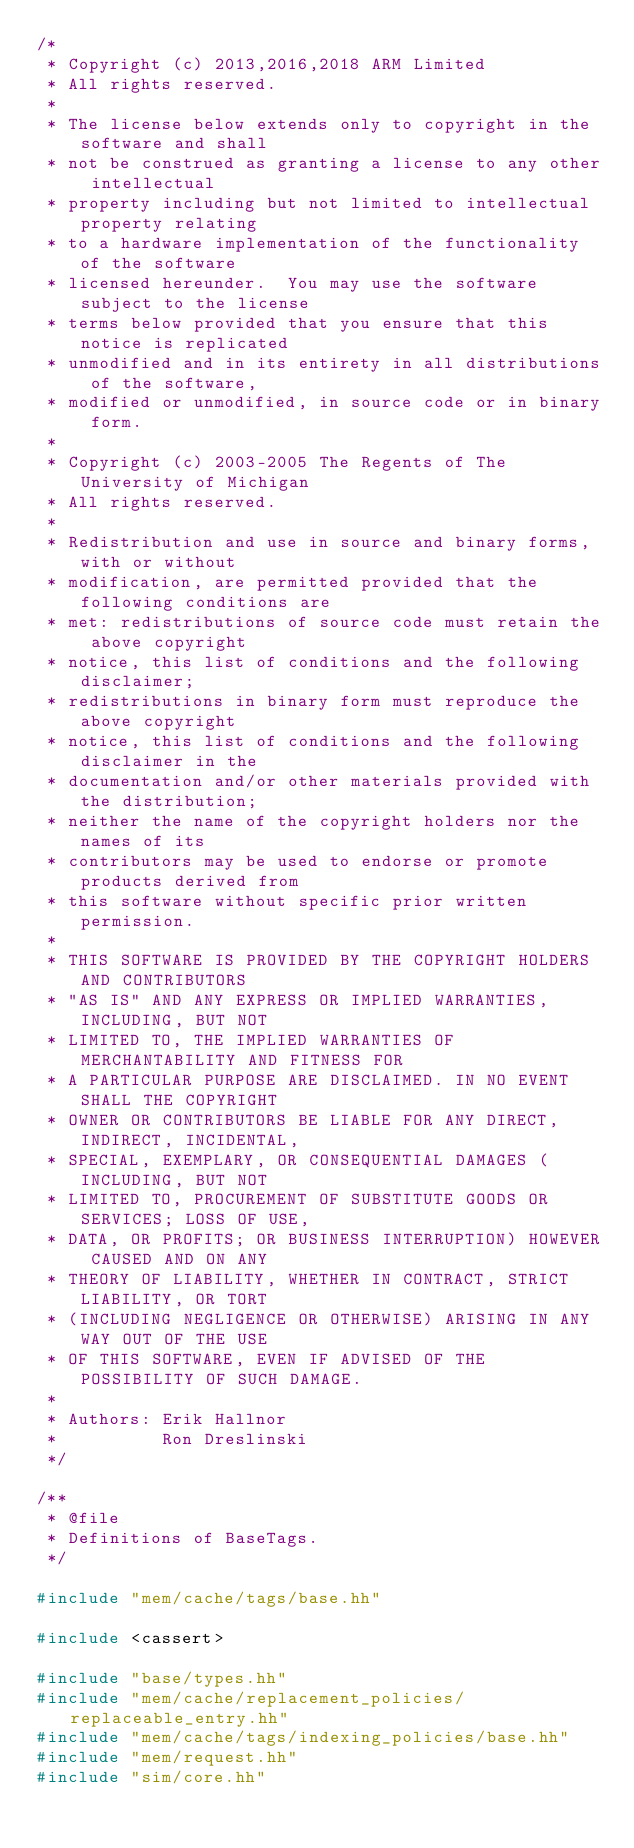Convert code to text. <code><loc_0><loc_0><loc_500><loc_500><_C++_>/*
 * Copyright (c) 2013,2016,2018 ARM Limited
 * All rights reserved.
 *
 * The license below extends only to copyright in the software and shall
 * not be construed as granting a license to any other intellectual
 * property including but not limited to intellectual property relating
 * to a hardware implementation of the functionality of the software
 * licensed hereunder.  You may use the software subject to the license
 * terms below provided that you ensure that this notice is replicated
 * unmodified and in its entirety in all distributions of the software,
 * modified or unmodified, in source code or in binary form.
 *
 * Copyright (c) 2003-2005 The Regents of The University of Michigan
 * All rights reserved.
 *
 * Redistribution and use in source and binary forms, with or without
 * modification, are permitted provided that the following conditions are
 * met: redistributions of source code must retain the above copyright
 * notice, this list of conditions and the following disclaimer;
 * redistributions in binary form must reproduce the above copyright
 * notice, this list of conditions and the following disclaimer in the
 * documentation and/or other materials provided with the distribution;
 * neither the name of the copyright holders nor the names of its
 * contributors may be used to endorse or promote products derived from
 * this software without specific prior written permission.
 *
 * THIS SOFTWARE IS PROVIDED BY THE COPYRIGHT HOLDERS AND CONTRIBUTORS
 * "AS IS" AND ANY EXPRESS OR IMPLIED WARRANTIES, INCLUDING, BUT NOT
 * LIMITED TO, THE IMPLIED WARRANTIES OF MERCHANTABILITY AND FITNESS FOR
 * A PARTICULAR PURPOSE ARE DISCLAIMED. IN NO EVENT SHALL THE COPYRIGHT
 * OWNER OR CONTRIBUTORS BE LIABLE FOR ANY DIRECT, INDIRECT, INCIDENTAL,
 * SPECIAL, EXEMPLARY, OR CONSEQUENTIAL DAMAGES (INCLUDING, BUT NOT
 * LIMITED TO, PROCUREMENT OF SUBSTITUTE GOODS OR SERVICES; LOSS OF USE,
 * DATA, OR PROFITS; OR BUSINESS INTERRUPTION) HOWEVER CAUSED AND ON ANY
 * THEORY OF LIABILITY, WHETHER IN CONTRACT, STRICT LIABILITY, OR TORT
 * (INCLUDING NEGLIGENCE OR OTHERWISE) ARISING IN ANY WAY OUT OF THE USE
 * OF THIS SOFTWARE, EVEN IF ADVISED OF THE POSSIBILITY OF SUCH DAMAGE.
 *
 * Authors: Erik Hallnor
 *          Ron Dreslinski
 */

/**
 * @file
 * Definitions of BaseTags.
 */

#include "mem/cache/tags/base.hh"

#include <cassert>

#include "base/types.hh"
#include "mem/cache/replacement_policies/replaceable_entry.hh"
#include "mem/cache/tags/indexing_policies/base.hh"
#include "mem/request.hh"
#include "sim/core.hh"</code> 